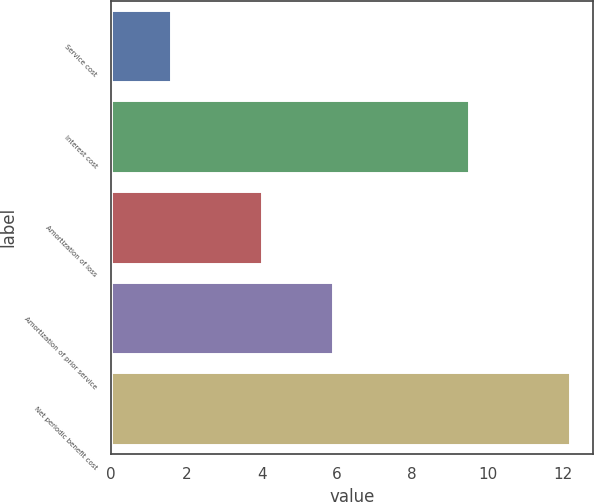Convert chart. <chart><loc_0><loc_0><loc_500><loc_500><bar_chart><fcel>Service cost<fcel>Interest cost<fcel>Amortization of loss<fcel>Amortization of prior service<fcel>Net periodic benefit cost<nl><fcel>1.6<fcel>9.5<fcel>4<fcel>5.9<fcel>12.2<nl></chart> 